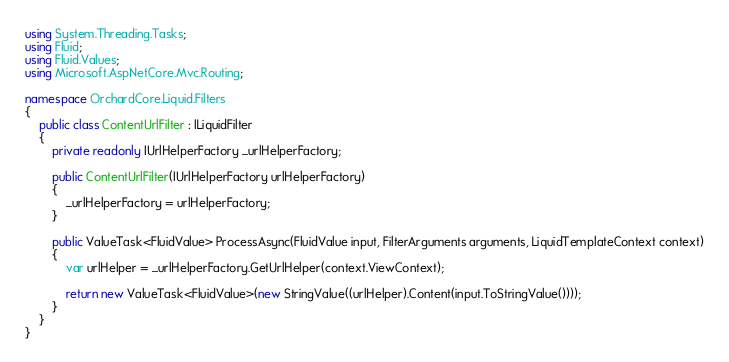Convert code to text. <code><loc_0><loc_0><loc_500><loc_500><_C#_>using System.Threading.Tasks;
using Fluid;
using Fluid.Values;
using Microsoft.AspNetCore.Mvc.Routing;

namespace OrchardCore.Liquid.Filters
{
    public class ContentUrlFilter : ILiquidFilter
    {
        private readonly IUrlHelperFactory _urlHelperFactory;

        public ContentUrlFilter(IUrlHelperFactory urlHelperFactory)
        {
            _urlHelperFactory = urlHelperFactory;
        }

        public ValueTask<FluidValue> ProcessAsync(FluidValue input, FilterArguments arguments, LiquidTemplateContext context)
        {
            var urlHelper = _urlHelperFactory.GetUrlHelper(context.ViewContext);

            return new ValueTask<FluidValue>(new StringValue((urlHelper).Content(input.ToStringValue())));
        }
    }
}
</code> 